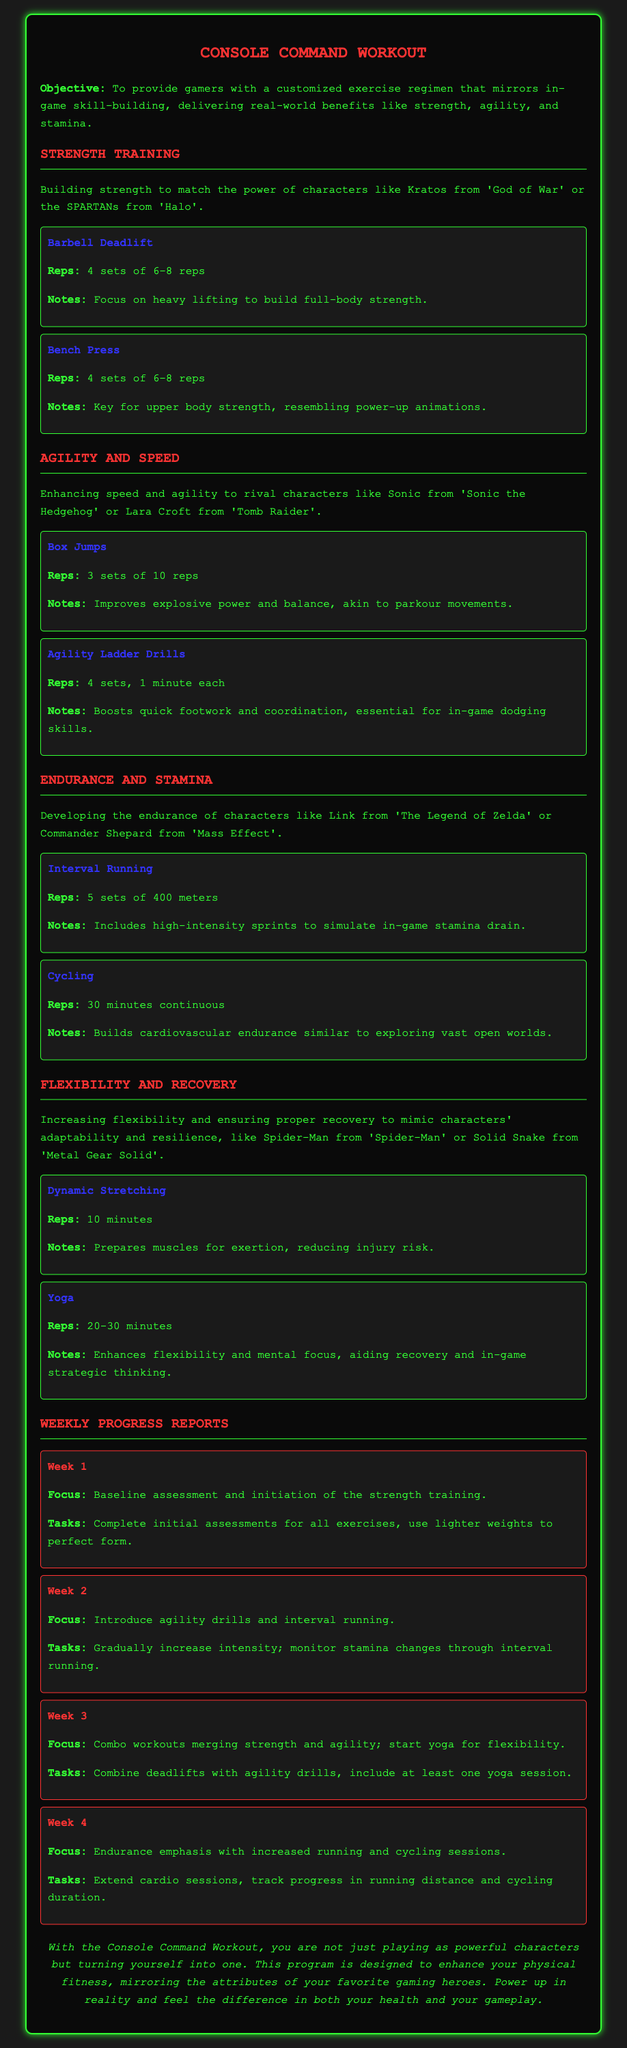What is the objective of the workout plan? The objective states the goal to provide gamers with a customized exercise regimen that mirrors in-game skill-building.
Answer: To provide gamers with a customized exercise regimen that mirrors in-game skill-building How many sets of reps are assigned to the Barbell Deadlift? The document specifies that there are 4 sets of 6-8 reps for the Barbell Deadlift.
Answer: 4 sets of 6-8 reps Which character is referenced for Agility and Speed training? The document mentions Sonic from 'Sonic the Hedgehog' as a character linked to Agility and Speed training.
Answer: Sonic from 'Sonic the Hedgehog' What is the focus for Week 3 of the workout? The focus for Week 3 combines workouts merging strength and agility, while introducing yoga for flexibility.
Answer: Combo workouts merging strength and agility; start yoga for flexibility What exercise is suggested for increasing flexibility? The document lists Yoga as an exercise to enhance flexibility.
Answer: Yoga How many minutes of Dynamic Stretching are recommended? The document states that 10 minutes of Dynamic Stretching are recommended.
Answer: 10 minutes Which week includes interval running? Week 2 is highlighted for introducing interval running and agility drills.
Answer: Week 2 What is the total duration suggested for Cycling? The document indicates that the recommended duration for Cycling is 30 minutes continuous.
Answer: 30 minutes continuous What color is the text color in the document? The primary text color in the document is specified as #33ff33.
Answer: #33ff33 